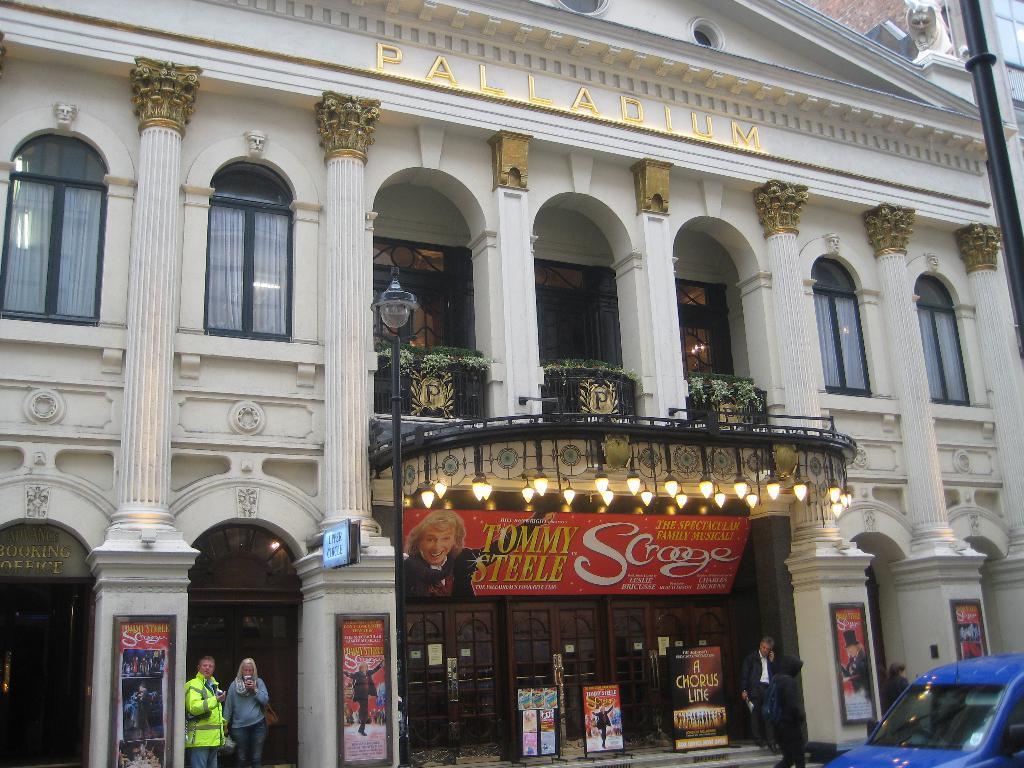How would you summarize this image in a sentence or two? In this image in the front there is a car which is blue in colour. In the background there are persons and there is a building and on the building there are boards which some text written on it and on the top of the building there is a text written on the wall of the building. In front of the building there is a pole which is black in colour and on the right side there is a wall and there is a statue. 